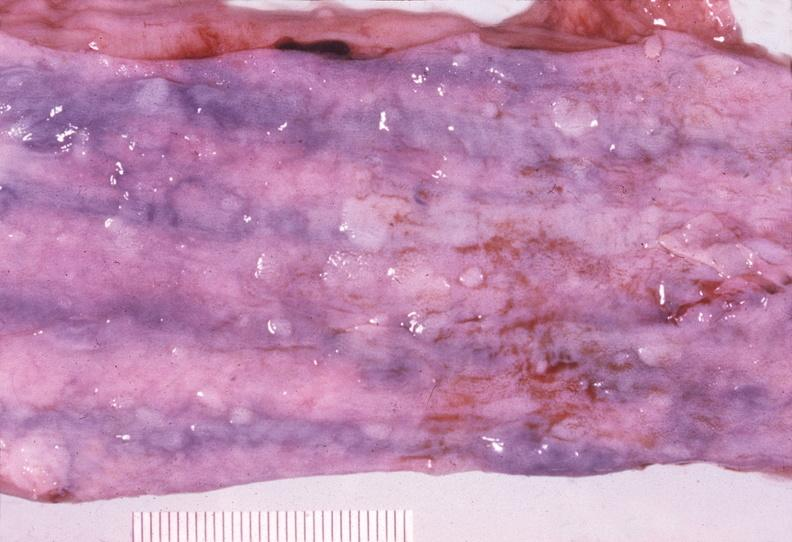does outside adrenal capsule section show esophagus, varices?
Answer the question using a single word or phrase. No 